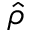Convert formula to latex. <formula><loc_0><loc_0><loc_500><loc_500>\hat { \rho }</formula> 